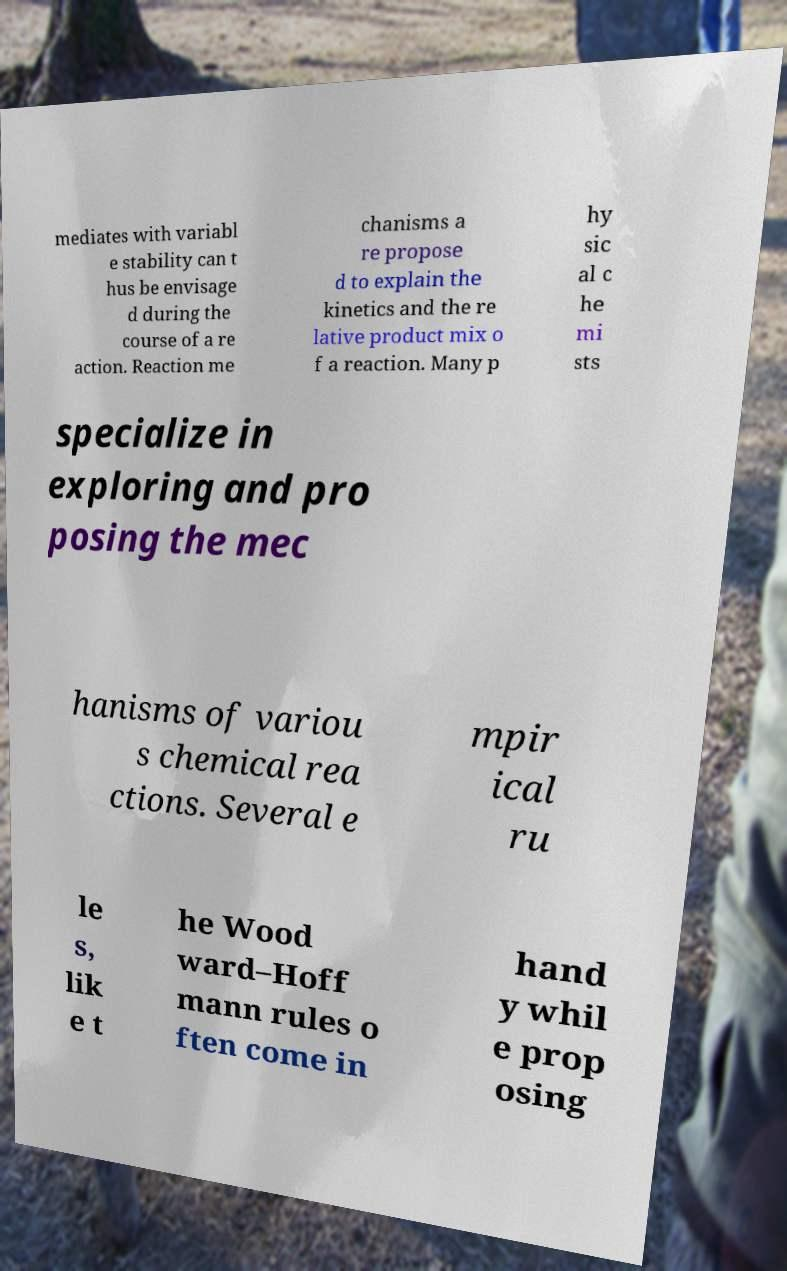Can you read and provide the text displayed in the image?This photo seems to have some interesting text. Can you extract and type it out for me? mediates with variabl e stability can t hus be envisage d during the course of a re action. Reaction me chanisms a re propose d to explain the kinetics and the re lative product mix o f a reaction. Many p hy sic al c he mi sts specialize in exploring and pro posing the mec hanisms of variou s chemical rea ctions. Several e mpir ical ru le s, lik e t he Wood ward–Hoff mann rules o ften come in hand y whil e prop osing 